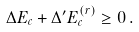Convert formula to latex. <formula><loc_0><loc_0><loc_500><loc_500>\Delta E _ { c } + \Delta ^ { \prime } E _ { c } ^ { ( r ) } \geq 0 \, .</formula> 